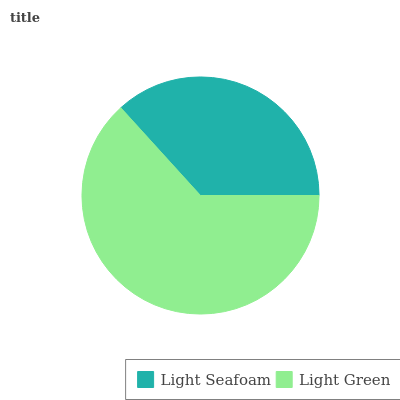Is Light Seafoam the minimum?
Answer yes or no. Yes. Is Light Green the maximum?
Answer yes or no. Yes. Is Light Green the minimum?
Answer yes or no. No. Is Light Green greater than Light Seafoam?
Answer yes or no. Yes. Is Light Seafoam less than Light Green?
Answer yes or no. Yes. Is Light Seafoam greater than Light Green?
Answer yes or no. No. Is Light Green less than Light Seafoam?
Answer yes or no. No. Is Light Green the high median?
Answer yes or no. Yes. Is Light Seafoam the low median?
Answer yes or no. Yes. Is Light Seafoam the high median?
Answer yes or no. No. Is Light Green the low median?
Answer yes or no. No. 